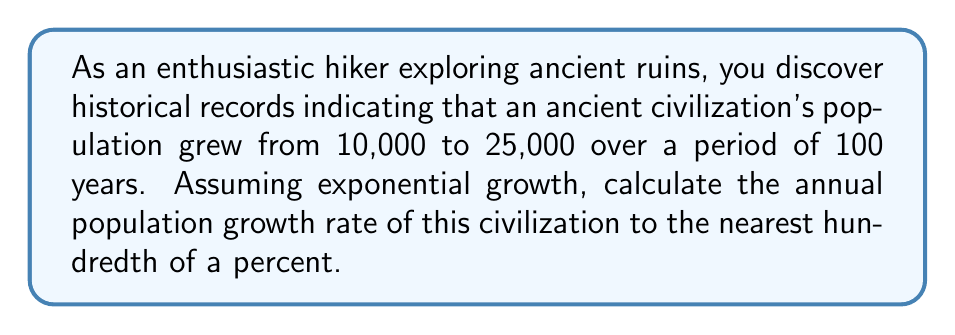What is the answer to this math problem? To solve this problem, we'll use the exponential growth formula:

$$A = P(1 + r)^t$$

Where:
$A$ = Final population (25,000)
$P$ = Initial population (10,000)
$r$ = Annual growth rate (decimal form)
$t$ = Time period (100 years)

Step 1: Substitute the known values into the formula:
$$25000 = 10000(1 + r)^{100}$$

Step 2: Divide both sides by 10000:
$$2.5 = (1 + r)^{100}$$

Step 3: Take the 100th root of both sides:
$$(2.5)^{\frac{1}{100}} = 1 + r$$

Step 4: Subtract 1 from both sides:
$$(2.5)^{\frac{1}{100}} - 1 = r$$

Step 5: Calculate the value of r:
$$r \approx 0.009228$$

Step 6: Convert to a percentage by multiplying by 100:
$$0.009228 \times 100 \approx 0.9228\%$$

Step 7: Round to the nearest hundredth of a percent:
$$0.92\%$$
Answer: 0.92% 